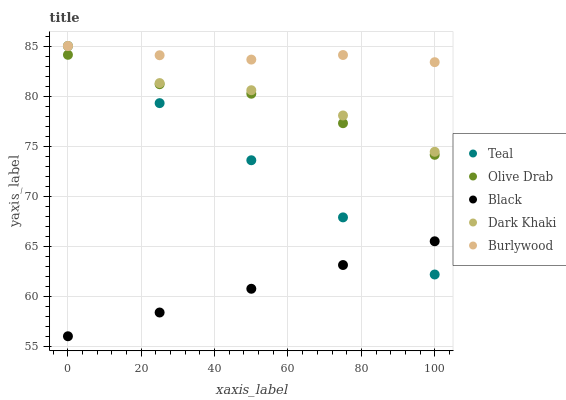Does Black have the minimum area under the curve?
Answer yes or no. Yes. Does Burlywood have the maximum area under the curve?
Answer yes or no. Yes. Does Burlywood have the minimum area under the curve?
Answer yes or no. No. Does Black have the maximum area under the curve?
Answer yes or no. No. Is Teal the smoothest?
Answer yes or no. Yes. Is Dark Khaki the roughest?
Answer yes or no. Yes. Is Burlywood the smoothest?
Answer yes or no. No. Is Burlywood the roughest?
Answer yes or no. No. Does Black have the lowest value?
Answer yes or no. Yes. Does Burlywood have the lowest value?
Answer yes or no. No. Does Teal have the highest value?
Answer yes or no. Yes. Does Black have the highest value?
Answer yes or no. No. Is Black less than Burlywood?
Answer yes or no. Yes. Is Dark Khaki greater than Black?
Answer yes or no. Yes. Does Burlywood intersect Teal?
Answer yes or no. Yes. Is Burlywood less than Teal?
Answer yes or no. No. Is Burlywood greater than Teal?
Answer yes or no. No. Does Black intersect Burlywood?
Answer yes or no. No. 